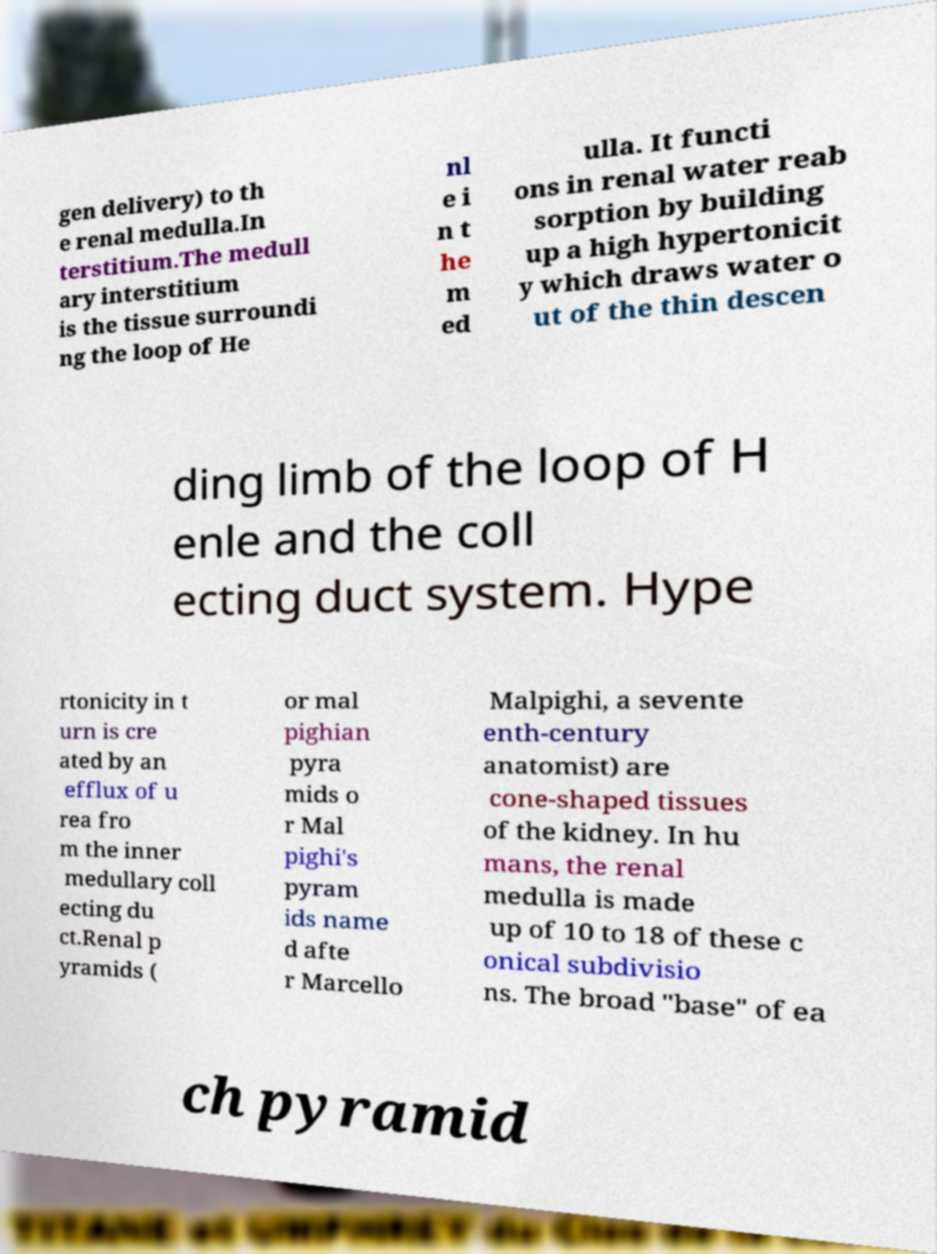Please read and relay the text visible in this image. What does it say? gen delivery) to th e renal medulla.In terstitium.The medull ary interstitium is the tissue surroundi ng the loop of He nl e i n t he m ed ulla. It functi ons in renal water reab sorption by building up a high hypertonicit y which draws water o ut of the thin descen ding limb of the loop of H enle and the coll ecting duct system. Hype rtonicity in t urn is cre ated by an efflux of u rea fro m the inner medullary coll ecting du ct.Renal p yramids ( or mal pighian pyra mids o r Mal pighi's pyram ids name d afte r Marcello Malpighi, a sevente enth-century anatomist) are cone-shaped tissues of the kidney. In hu mans, the renal medulla is made up of 10 to 18 of these c onical subdivisio ns. The broad "base" of ea ch pyramid 